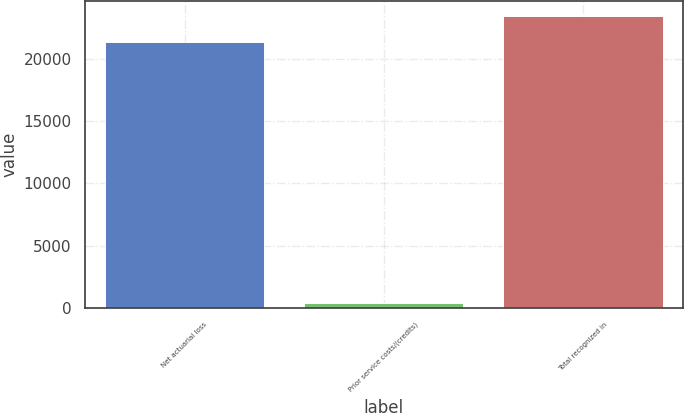Convert chart to OTSL. <chart><loc_0><loc_0><loc_500><loc_500><bar_chart><fcel>Net actuarial loss<fcel>Prior service costs/(credits)<fcel>Total recognized in<nl><fcel>21321<fcel>385<fcel>23453.1<nl></chart> 